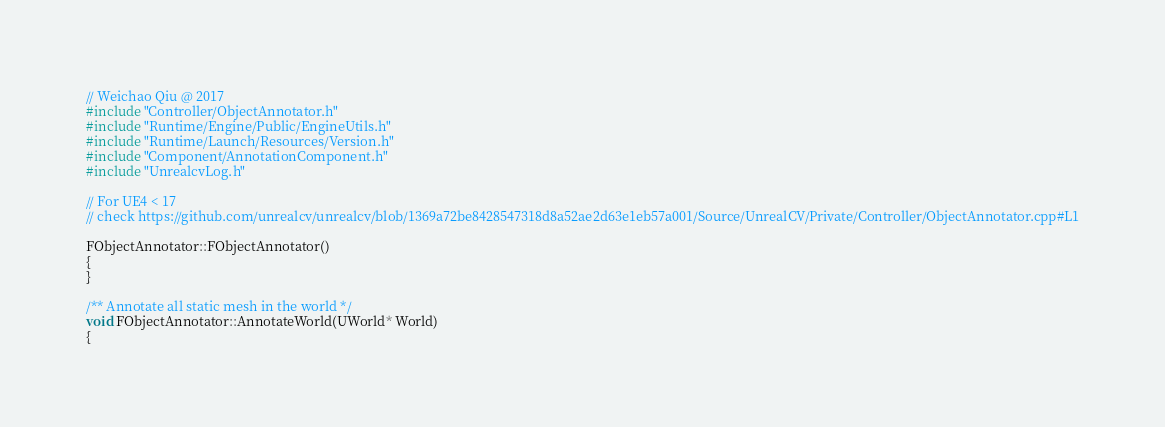<code> <loc_0><loc_0><loc_500><loc_500><_C++_>// Weichao Qiu @ 2017
#include "Controller/ObjectAnnotator.h"
#include "Runtime/Engine/Public/EngineUtils.h"
#include "Runtime/Launch/Resources/Version.h"
#include "Component/AnnotationComponent.h"
#include "UnrealcvLog.h"

// For UE4 < 17
// check https://github.com/unrealcv/unrealcv/blob/1369a72be8428547318d8a52ae2d63e1eb57a001/Source/UnrealCV/Private/Controller/ObjectAnnotator.cpp#L1

FObjectAnnotator::FObjectAnnotator()
{
}

/** Annotate all static mesh in the world */
void FObjectAnnotator::AnnotateWorld(UWorld* World)
{</code> 